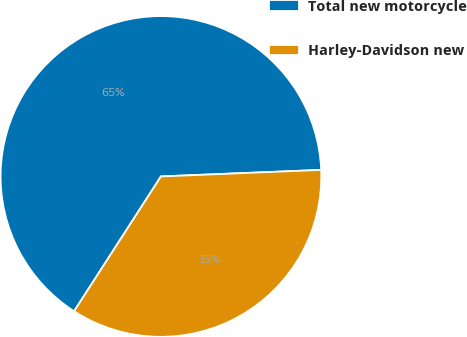Convert chart. <chart><loc_0><loc_0><loc_500><loc_500><pie_chart><fcel>Total new motorcycle<fcel>Harley-Davidson new<nl><fcel>65.24%<fcel>34.76%<nl></chart> 